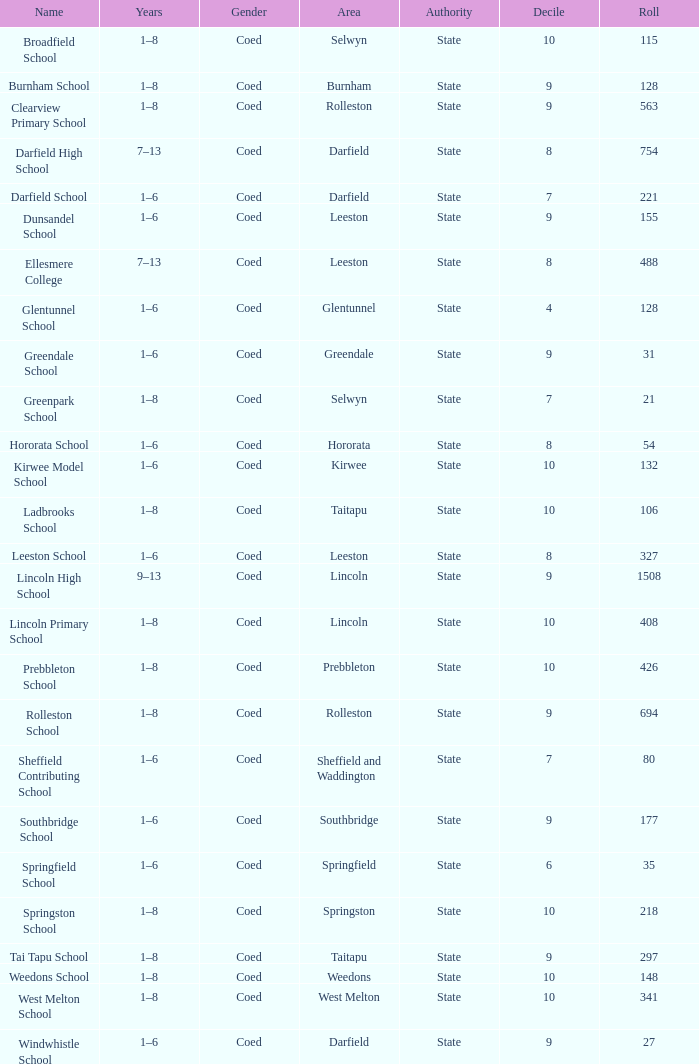What is the total of the roll with a Decile of 8, and an Area of hororata? 54.0. 